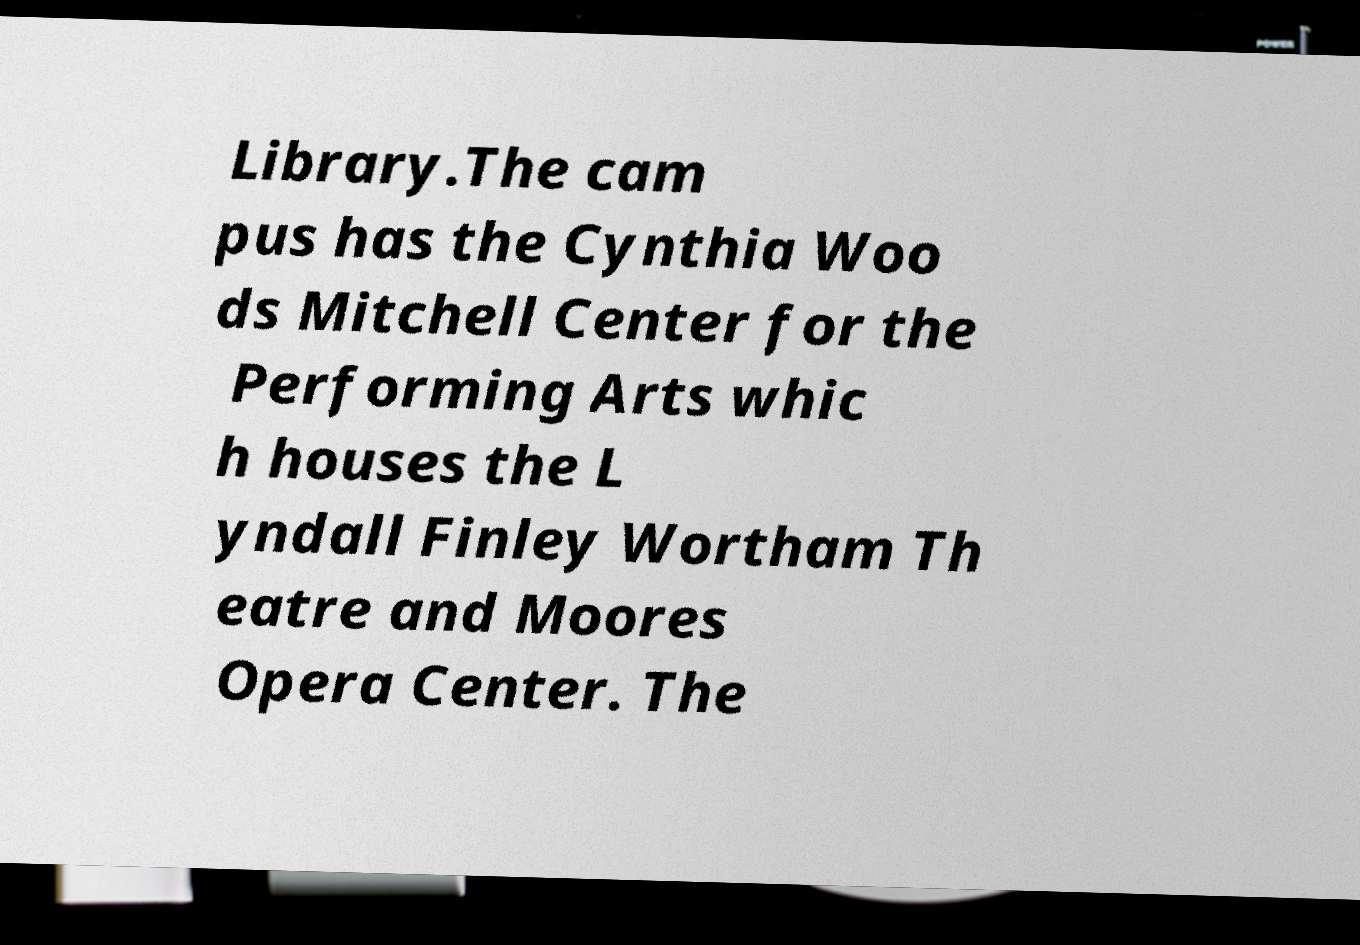What messages or text are displayed in this image? I need them in a readable, typed format. Library.The cam pus has the Cynthia Woo ds Mitchell Center for the Performing Arts whic h houses the L yndall Finley Wortham Th eatre and Moores Opera Center. The 